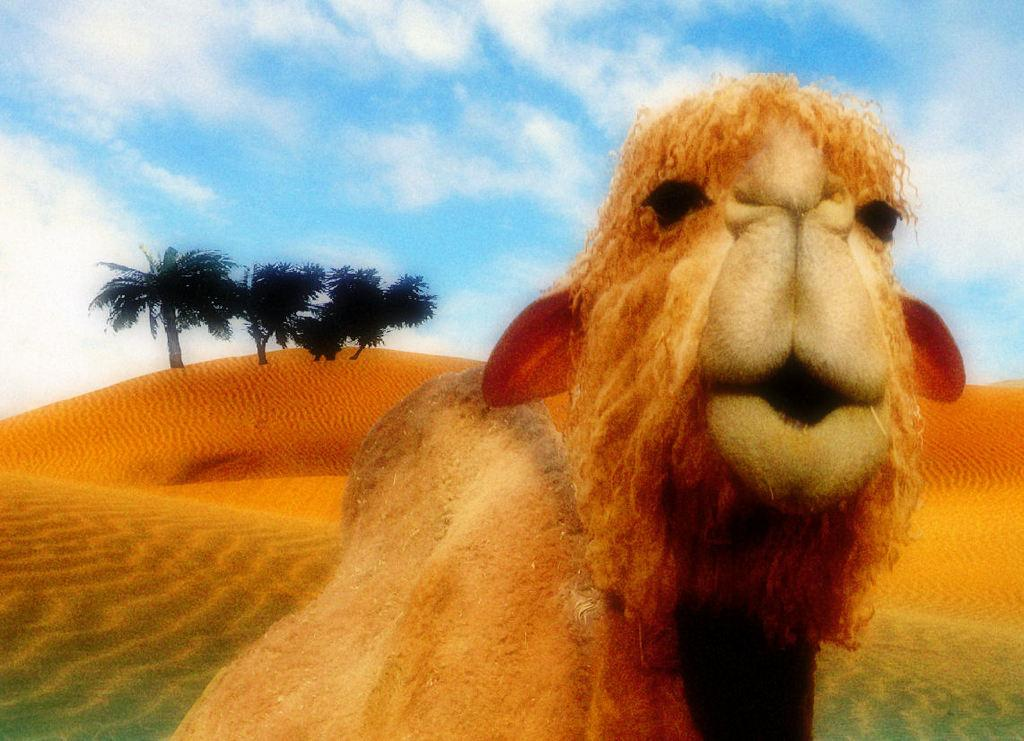What type of living creature is in the image? There is an animal in the image. What type of natural environment can be seen in the image? There are trees visible in the image. What is the condition of the sky in the image? The sky is cloudy in the image. Where is the stove located in the image? There is no stove present in the image. What type of throne can be seen in the image? There is no throne present in the image. 